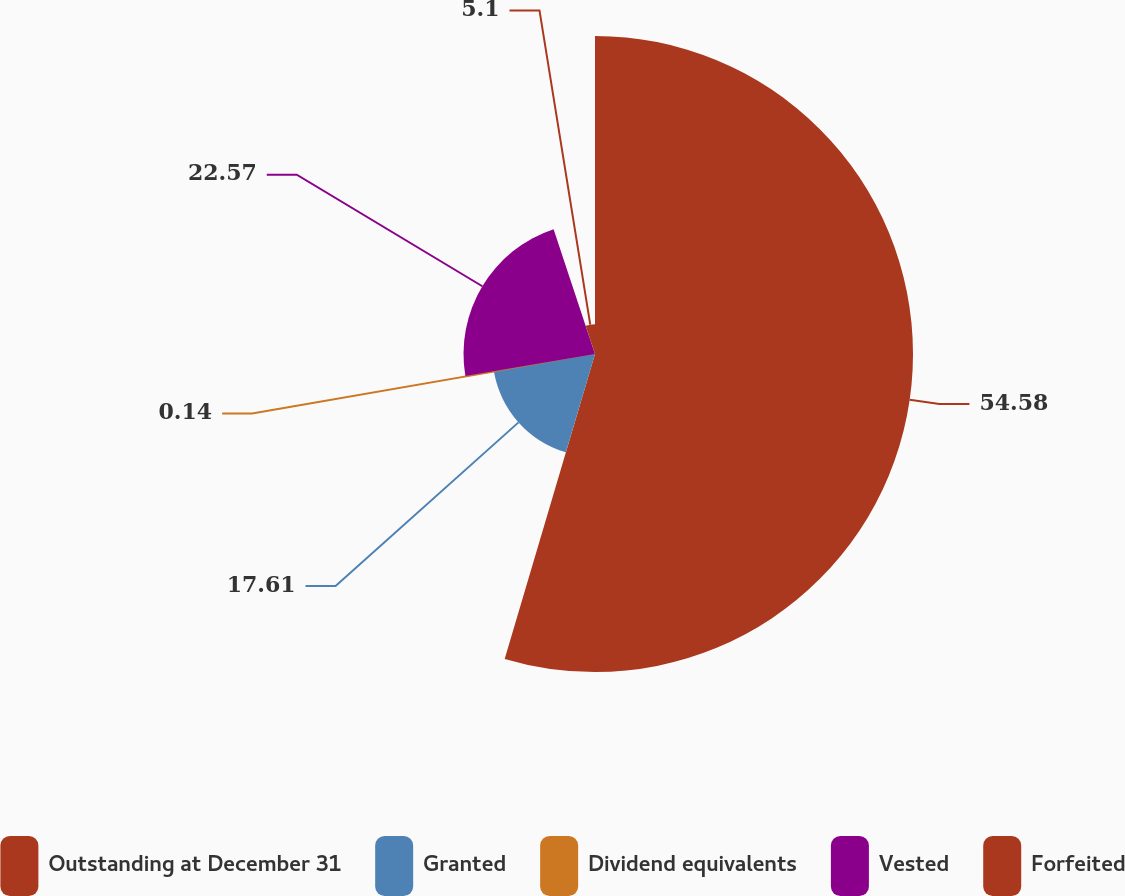Convert chart. <chart><loc_0><loc_0><loc_500><loc_500><pie_chart><fcel>Outstanding at December 31<fcel>Granted<fcel>Dividend equivalents<fcel>Vested<fcel>Forfeited<nl><fcel>54.59%<fcel>17.61%<fcel>0.14%<fcel>22.57%<fcel>5.1%<nl></chart> 